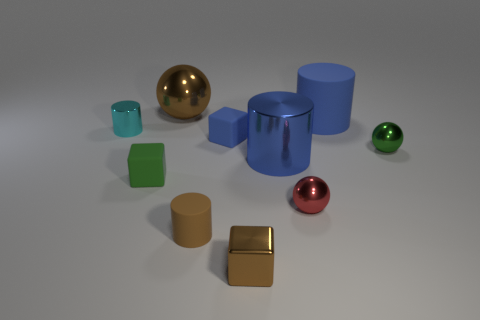Subtract all brown cylinders. How many cylinders are left? 3 Subtract all cyan cylinders. How many cylinders are left? 3 Subtract all gray cylinders. Subtract all gray balls. How many cylinders are left? 4 Subtract all spheres. How many objects are left? 7 Add 3 blocks. How many blocks exist? 6 Subtract 0 cyan balls. How many objects are left? 10 Subtract all tiny purple cylinders. Subtract all small objects. How many objects are left? 3 Add 2 small brown metallic cubes. How many small brown metallic cubes are left? 3 